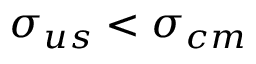<formula> <loc_0><loc_0><loc_500><loc_500>\sigma _ { u s } < \sigma _ { c m }</formula> 